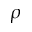<formula> <loc_0><loc_0><loc_500><loc_500>\rho</formula> 